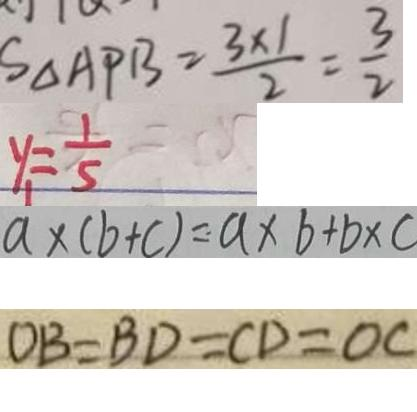Convert formula to latex. <formula><loc_0><loc_0><loc_500><loc_500>S _ { \Delta A P B } = \frac { 3 \times 1 } { 2 } = \frac { 3 } { 2 } 
 y _ { 1 } = \frac { 1 } { 5 } 
 a \times ( b + c ) = a \times b + b \times c 
 O B = B D = C D = O C</formula> 